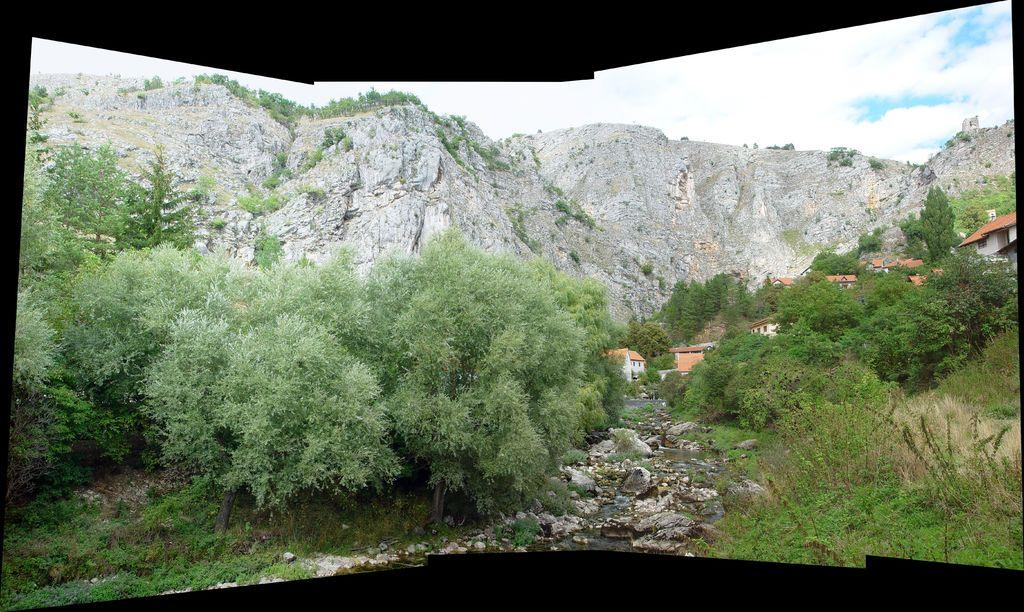What type of natural elements can be seen in the image? There are trees in the image. What type of man-made structures are present in the image? There are buildings in the image. What type of terrain is visible in the image? There are stones visible in the image. What can be seen in the background of the image? There is a hill and the sky visible in the background of the image. What is the condition of the sky in the image? The sky has clouds in the image. Can you tell me how many giraffes are standing near the buildings in the image? There are no giraffes present in the image; it features trees, buildings, stones, a hill, and the sky. What type of body is visible in the image? There is no specific body present in the image; it is a landscape scene with trees, buildings, stones, a hill, and the sky. 